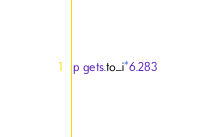<code> <loc_0><loc_0><loc_500><loc_500><_Ruby_>p gets.to_i*6.283</code> 